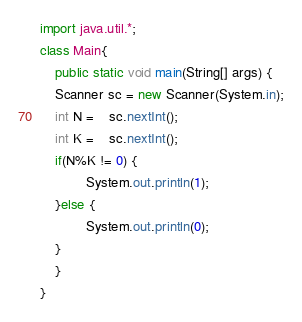Convert code to text. <code><loc_0><loc_0><loc_500><loc_500><_Java_>import java.util.*;
class Main{
    public static void main(String[] args) {
	Scanner sc = new Scanner(System.in);
	int N =	sc.nextInt();
	int K =	sc.nextInt();
	if(N%K != 0) {
            System.out.println(1);
	}else {
            System.out.println(0);
	}
    }
}</code> 